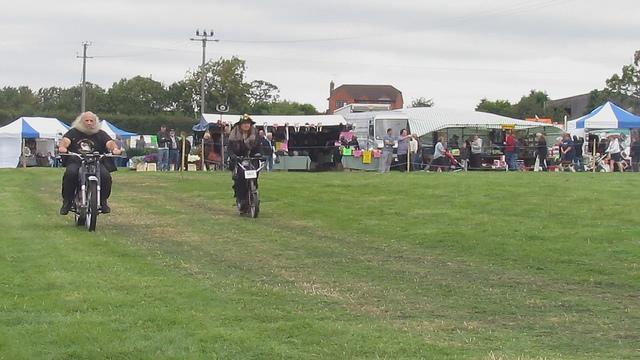What type food is more likely served here?
Indicate the correct choice and explain in the format: 'Answer: answer
Rationale: rationale.'
Options: Salads, filet mignon, hot dog, chile. Answer: hot dog.
Rationale: The food is the hot dog. 